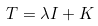<formula> <loc_0><loc_0><loc_500><loc_500>T = \lambda I + K</formula> 